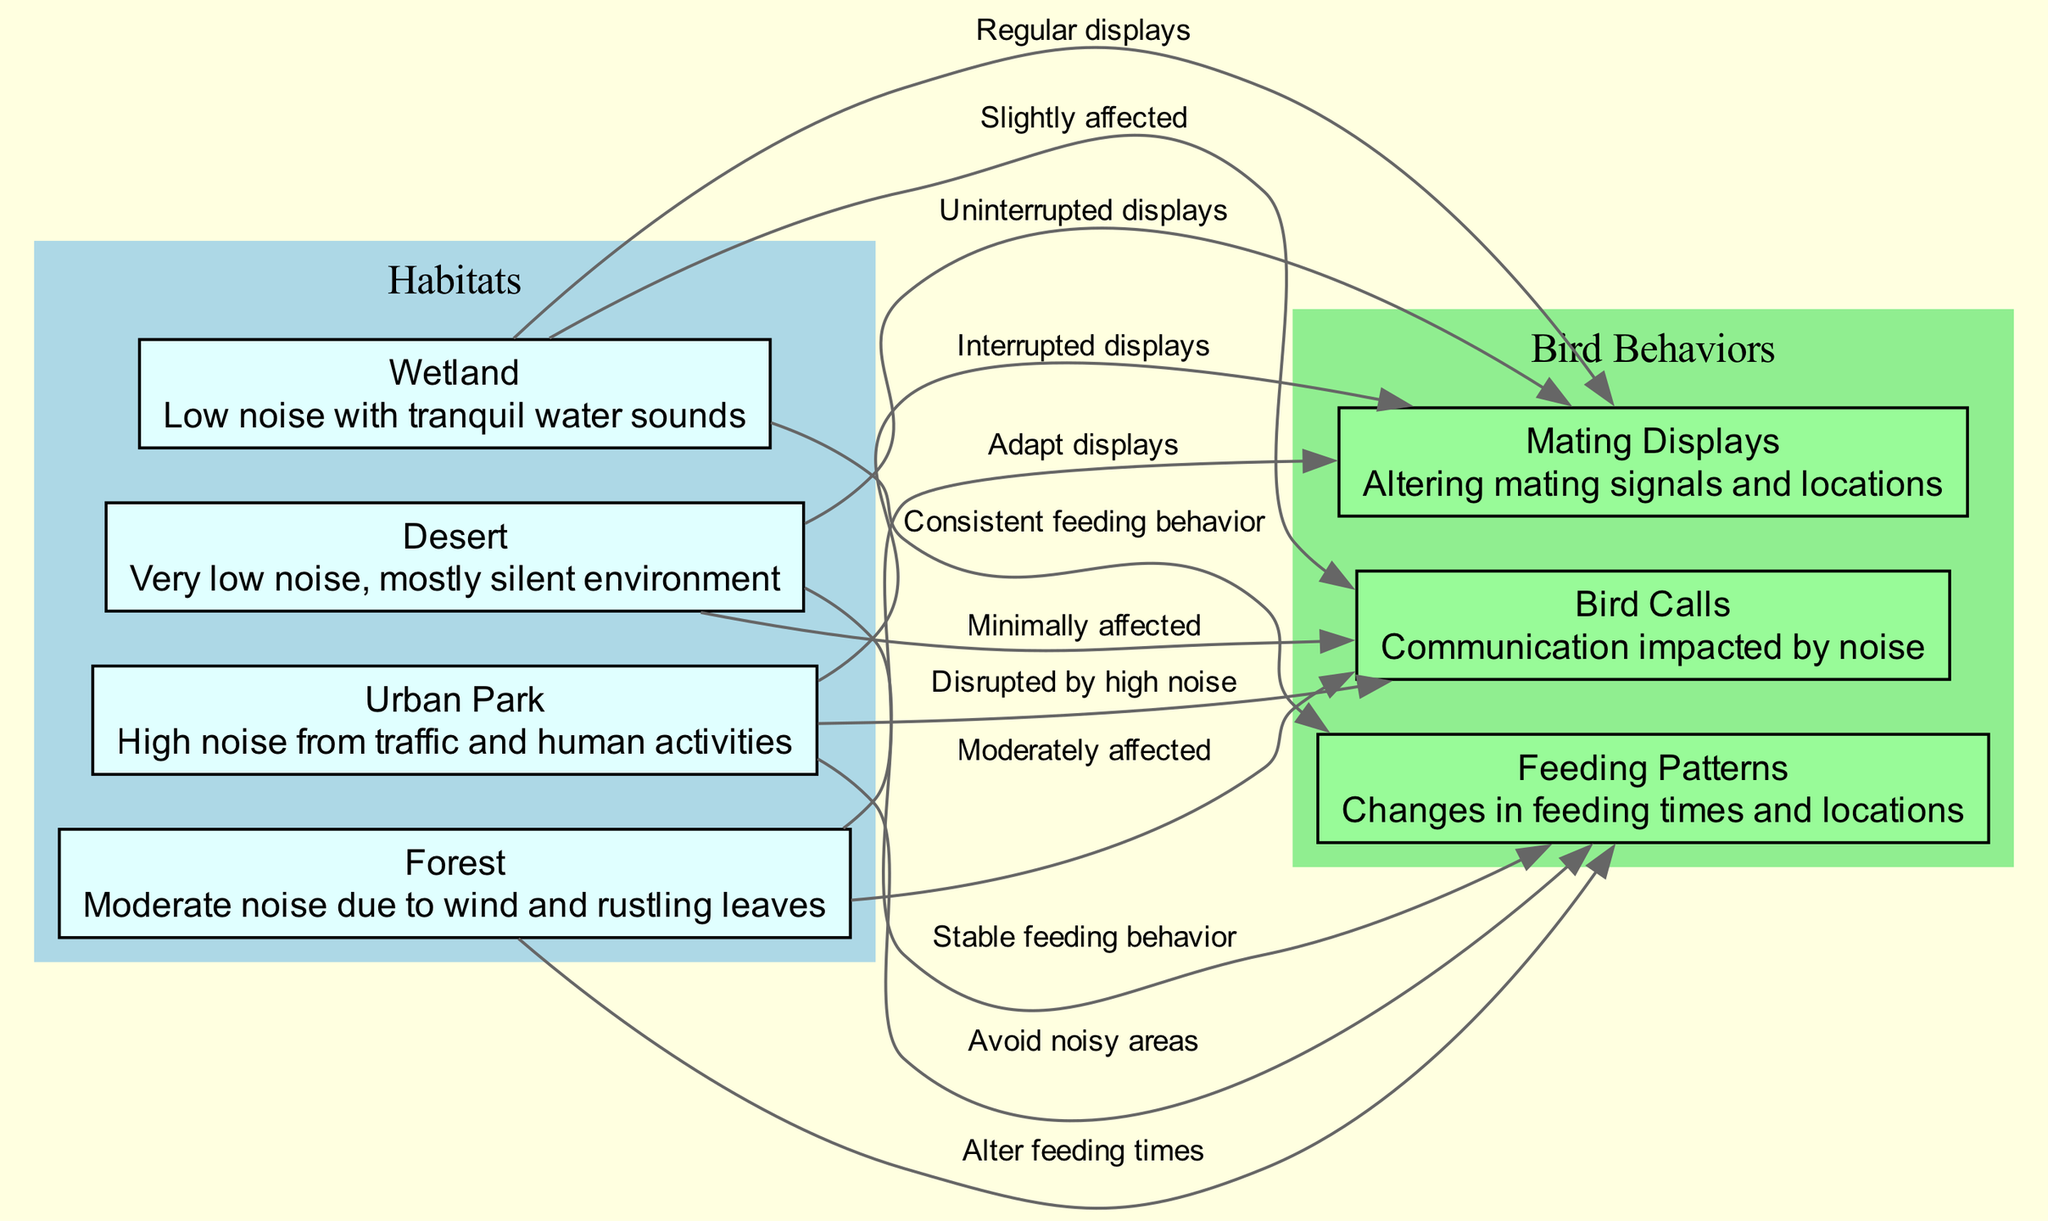What is the noise level in an Urban Park? The diagram describes Urban Park as having "High noise from traffic and human activities".
Answer: High noise Which bird habitat has the lowest noise levels? According to the diagram, the Desert habitat is labeled as "Very low noise, mostly silent environment".
Answer: Desert How are bird calls affected in Wetland? The Wetland is connected to bird calls with a label stating "Slightly affected", indicating the degree of impact on communication.
Answer: Slightly affected What happens to Feeding Patterns in an Urban Park? The diagram shows a connection from the Urban Park to Feeding Patterns, labeled "Avoid noisy areas", indicating how noise influences feeding behavior.
Answer: Avoid noisy areas Which bird behavior is described as being "Interrupted" in Urban Park? There is a direct connection labeled "Interrupted displays" from Urban Park to Mating Displays, indicating that this behavior is significantly affected.
Answer: Mating Displays In which habitat do birds exhibit "Uninterrupted displays"? According to the diagram, the Desert habitat has a link to Mating Displays with a label "Uninterrupted displays", showing this behavior remains consistent there.
Answer: Desert How many edges connect Urban Park to bird behaviors? The diagram shows three edges leading from Urban Park to bird behaviors: bird calls, feeding patterns, and mating displays. Therefore, there are three connections.
Answer: Three What is the relationship between Forest and Feeding Patterns? The edge from Forest to Feeding Patterns is labeled "Alter feeding times", indicating this habitat significantly influences changes in how birds feed.
Answer: Alter feeding times Which habitats maintain consistent feeding behavior? According to the diagram, Wetland shows a link labeled "Consistent feeding behavior", indicating stability in feeding compared to other habitats.
Answer: Wetland 